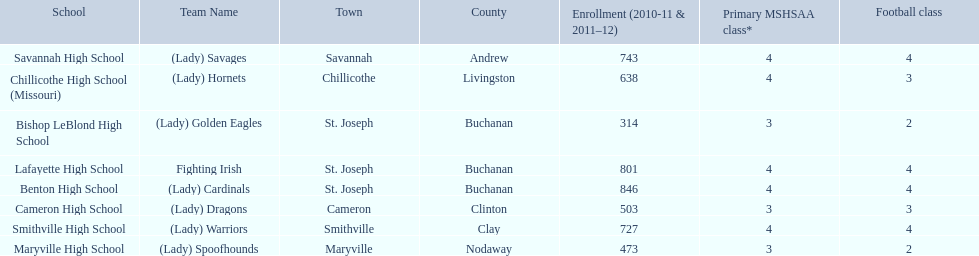What are the names of the schools? Benton High School, Bishop LeBlond High School, Cameron High School, Chillicothe High School (Missouri), Lafayette High School, Maryville High School, Savannah High School, Smithville High School. Of those, which had a total enrollment of less than 500? Bishop LeBlond High School, Maryville High School. And of those, which had the lowest enrollment? Bishop LeBlond High School. 